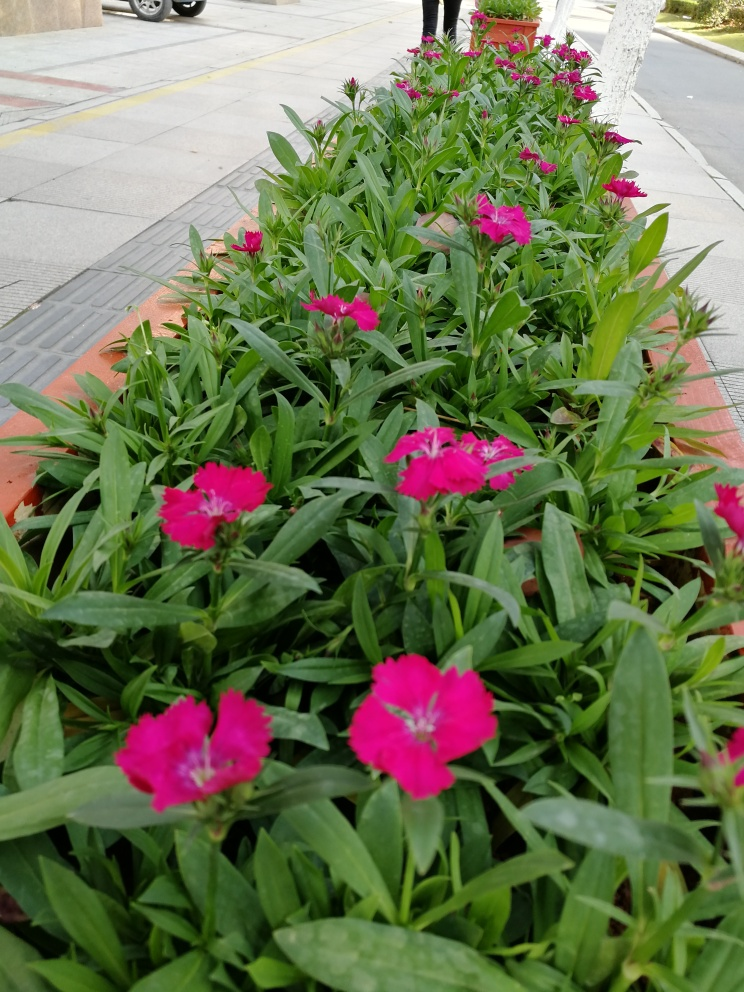What types of plants are these, and are they usually found in an urban setting? The plants in the image are pink flowers, which could be a variety of Dianthus. They are commonly used in urban landscaping due to their vibrant colors and ability to thrive in planters or flower beds along sidewalks or in parks. Do these flowers require special care or are they low-maintenance? These types of flowers are generally low-maintenance. They are often chosen for urban landscaping because they can withstand varying weather conditions and don't require extensive care beyond regular watering and occasional pruning to remove spent blossoms and encourage new growth. 